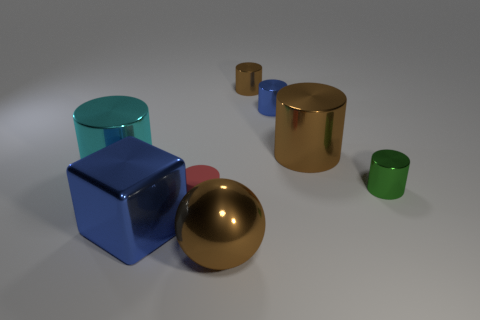Subtract all cyan cylinders. How many cylinders are left? 5 Subtract all green cylinders. How many cylinders are left? 5 Add 1 red matte objects. How many objects exist? 9 Subtract all cyan cylinders. Subtract all blue balls. How many cylinders are left? 5 Subtract all blocks. How many objects are left? 7 Add 4 green shiny blocks. How many green shiny blocks exist? 4 Subtract 0 red balls. How many objects are left? 8 Subtract all tiny metallic cylinders. Subtract all small cyan shiny spheres. How many objects are left? 5 Add 6 tiny shiny cylinders. How many tiny shiny cylinders are left? 9 